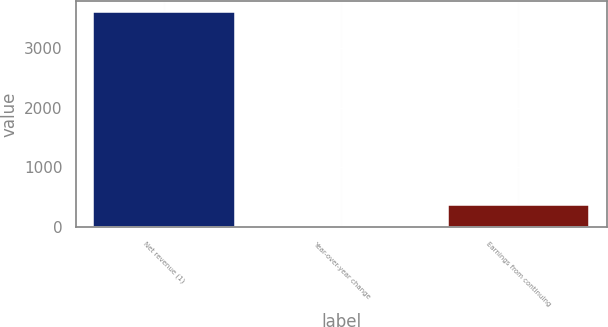<chart> <loc_0><loc_0><loc_500><loc_500><bar_chart><fcel>Net revenue (1)<fcel>Year-over-year change<fcel>Earnings from continuing<nl><fcel>3602<fcel>12.9<fcel>371.81<nl></chart> 